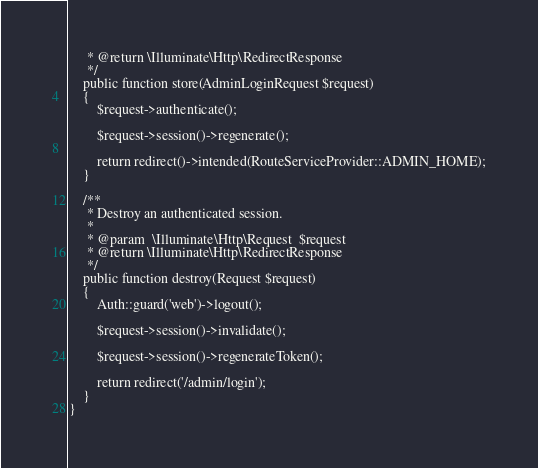<code> <loc_0><loc_0><loc_500><loc_500><_PHP_>     * @return \Illuminate\Http\RedirectResponse
     */
    public function store(AdminLoginRequest $request)
    {
        $request->authenticate();

        $request->session()->regenerate();

        return redirect()->intended(RouteServiceProvider::ADMIN_HOME);
    }

    /**
     * Destroy an authenticated session.
     *
     * @param  \Illuminate\Http\Request  $request
     * @return \Illuminate\Http\RedirectResponse
     */
    public function destroy(Request $request)
    {
        Auth::guard('web')->logout();

        $request->session()->invalidate();

        $request->session()->regenerateToken();

        return redirect('/admin/login');
    }
}
</code> 